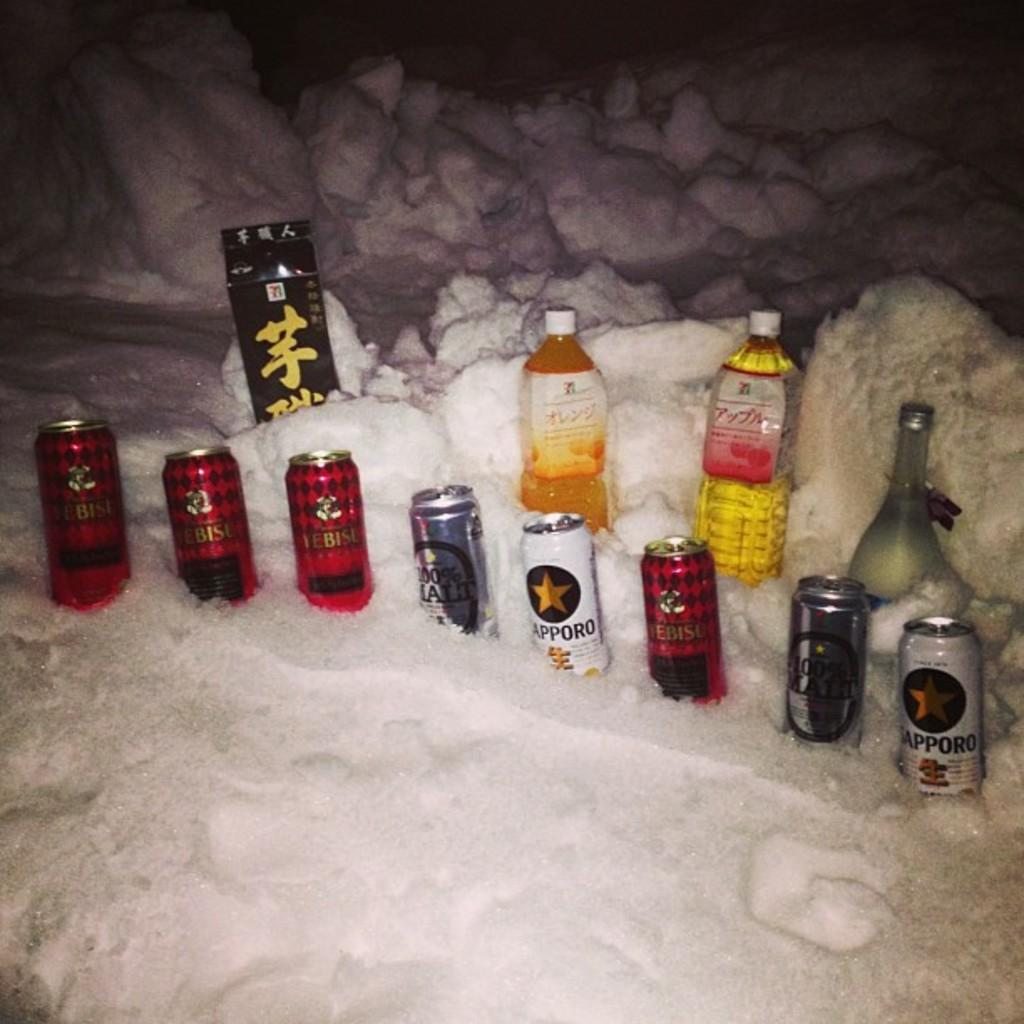<image>
Create a compact narrative representing the image presented. A few beers such as Sapporo sit in the snow. 